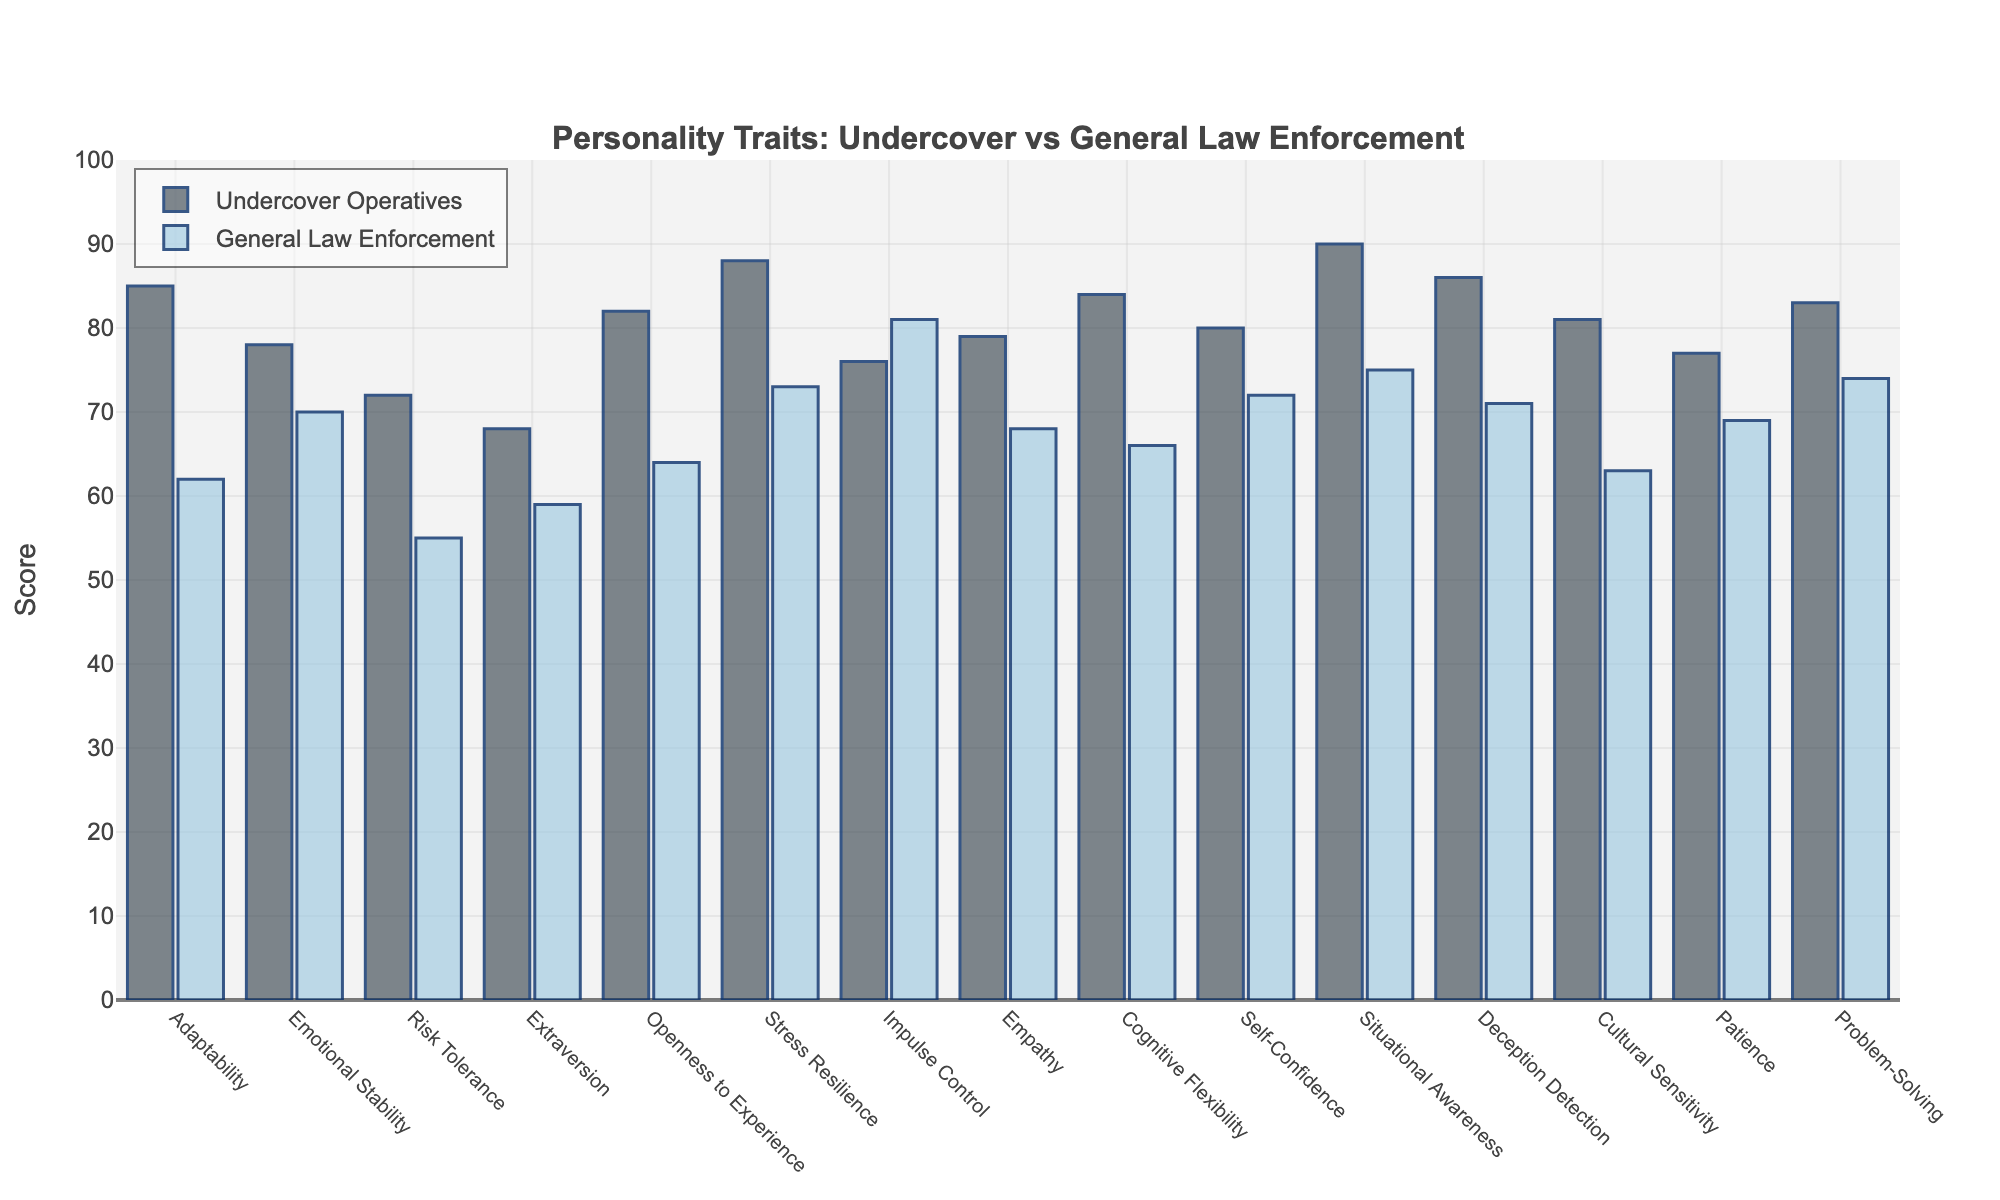Which personality trait shows the largest difference in scores between undercover operatives and general law enforcement? Situational Awareness shows the largest difference. Undercover operatives have a score of 90, while general law enforcement has a score of 75. The difference is 90 - 75 = 15.
Answer: Situational Awareness Which group scored higher in Impulse Control? General Law Enforcement scored higher in Impulse Control. General Law Enforcement has a score of 81, whereas Undercover Operatives have a score of 76.
Answer: General Law Enforcement What is the average score of Problem-Solving for both groups combined? The score for Problem-Solving is 83 for Undercover Operatives and 74 for General Law Enforcement. The average score is (83 + 74) / 2 = 78.5.
Answer: 78.5 For which traits do undercover operatives outperform general law enforcement by more than 10 points? The traits are Risk Tolerance, Openness to Experience, Cognitive Flexibility, Situational Awareness, Deception Detection, and Cultural Sensitivity.
Answer: Risk Tolerance, Openness to Experience, Cognitive Flexibility, Situational Awareness, Deception Detection, Cultural Sensitivity Which personality trait has the smallest difference in scores between the two groups? Impulse Control has the smallest difference: 76 for Undercover Operatives and 81 for General Law Enforcement. The difference is 81 - 76 = 5.
Answer: Impulse Control How many personality traits have a score above 80 for undercover operatives? The traits with a score above 80 for undercover operatives are Adaptability, Openness to Experience, Stress Resilience, Cognitive Flexibility, Situational Awareness, Deception Detection, Cultural Sensitivity, and Self-Confidence. There are 8 such traits.
Answer: 8 Is Emotional Stability higher in undercover operatives or general law enforcement? Emotional Stability is higher in undercover operatives with a score of 78 compared to 70 for general law enforcement.
Answer: Undercover Operatives What's the combined total score of Empathy for both groups? The score for Empathy is 79 for Undercover Operatives and 68 for General Law Enforcement. The combined total score is 79 + 68 = 147.
Answer: 147 Do undercover operatives show higher Adaptability than general law enforcement? By how much? Yes, undercover operatives have a score of 85 in Adaptability, whereas general law enforcement has a score of 62. The difference is 85 - 62 = 23.
Answer: Yes, by 23 What is the median score of Situational Awareness for both groups combined? The scores of Situational Awareness are 90 for Undercover Operatives and 75 for General Law Enforcement. Since there are only two values, the median is (90 + 75) / 2 = 82.5.
Answer: 82.5 